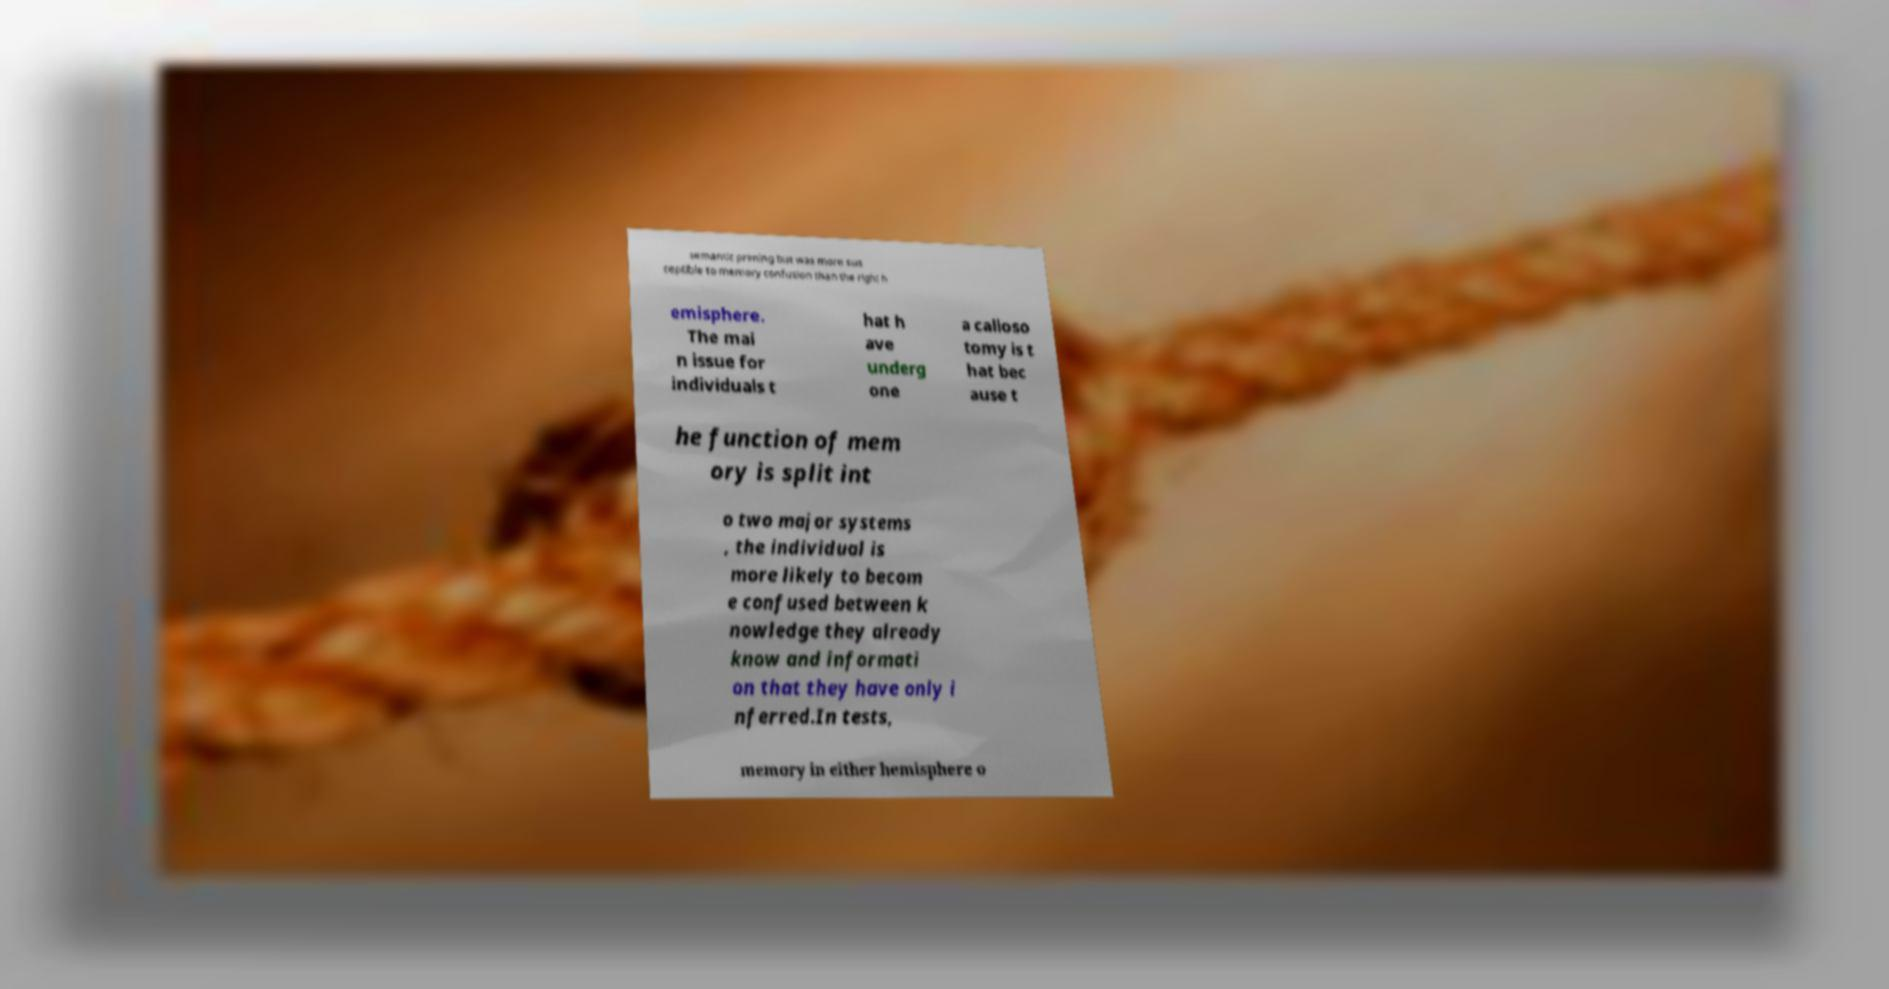Please read and relay the text visible in this image. What does it say? semantic priming but was more sus ceptible to memory confusion than the right h emisphere. The mai n issue for individuals t hat h ave underg one a calloso tomy is t hat bec ause t he function of mem ory is split int o two major systems , the individual is more likely to becom e confused between k nowledge they already know and informati on that they have only i nferred.In tests, memory in either hemisphere o 